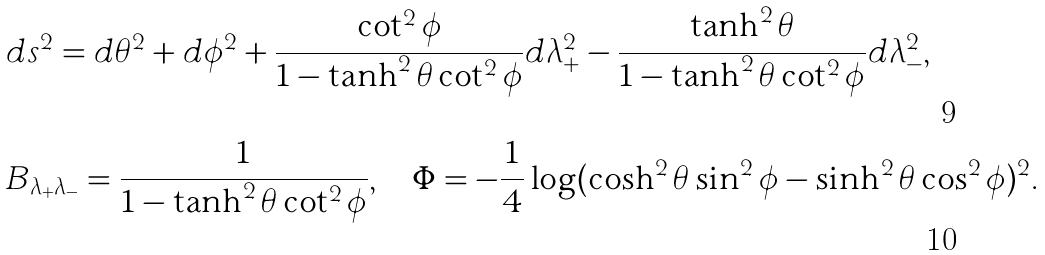Convert formula to latex. <formula><loc_0><loc_0><loc_500><loc_500>& d s ^ { 2 } = d \theta ^ { 2 } + d { \phi } ^ { 2 } + \frac { \cot ^ { 2 } \phi } { 1 - \tanh ^ { 2 } \theta \cot ^ { 2 } \phi } d \lambda ^ { 2 } _ { + } - \frac { \tanh ^ { 2 } \theta } { 1 - \tanh ^ { 2 } \theta \cot ^ { 2 } \phi } d \lambda ^ { 2 } _ { - } , \\ & B _ { \lambda _ { + } \lambda _ { - } } = \frac { 1 } { 1 - \tanh ^ { 2 } \theta \cot ^ { 2 } \phi } , \quad \Phi = - \frac { 1 } { 4 } \log ( \cosh ^ { 2 } \theta \sin ^ { 2 } \phi - \sinh ^ { 2 } \theta \cos ^ { 2 } \phi ) ^ { 2 } .</formula> 